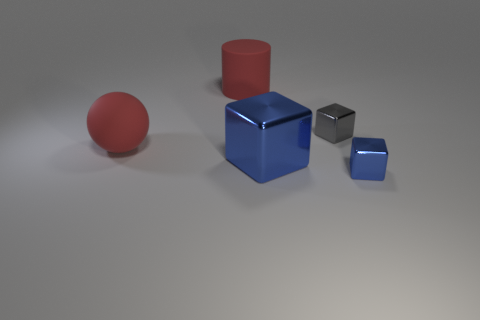Add 1 blue objects. How many objects exist? 6 Subtract all tiny gray metal cubes. How many cubes are left? 2 Subtract all red balls. How many blue cubes are left? 2 Subtract 1 cubes. How many cubes are left? 2 Subtract 0 brown balls. How many objects are left? 5 Subtract all cubes. How many objects are left? 2 Subtract all yellow blocks. Subtract all brown cylinders. How many blocks are left? 3 Subtract all blue shiny objects. Subtract all small purple balls. How many objects are left? 3 Add 4 small gray shiny cubes. How many small gray shiny cubes are left? 5 Add 5 big blue metal things. How many big blue metal things exist? 6 